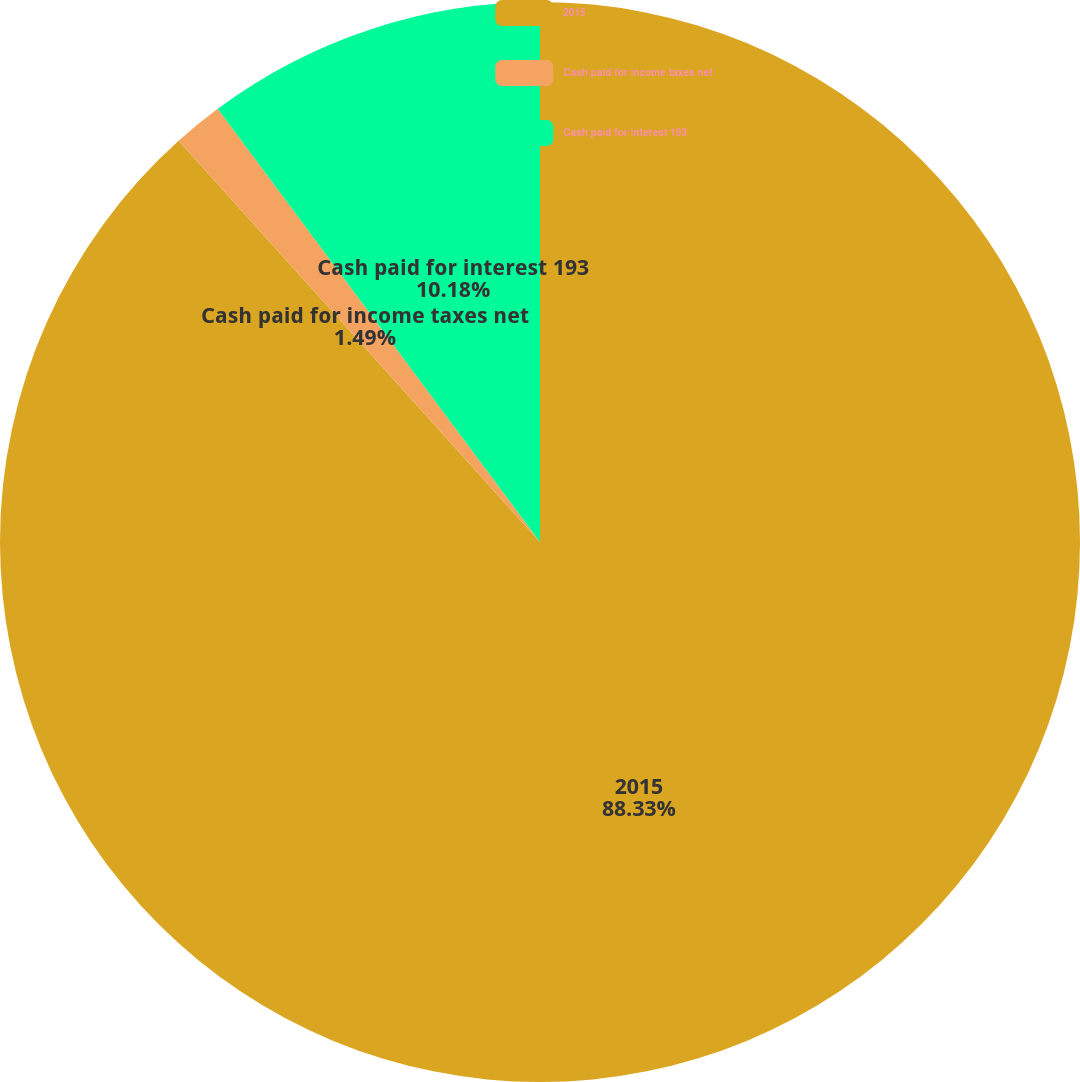Convert chart. <chart><loc_0><loc_0><loc_500><loc_500><pie_chart><fcel>2015<fcel>Cash paid for income taxes net<fcel>Cash paid for interest 193<nl><fcel>88.33%<fcel>1.49%<fcel>10.18%<nl></chart> 